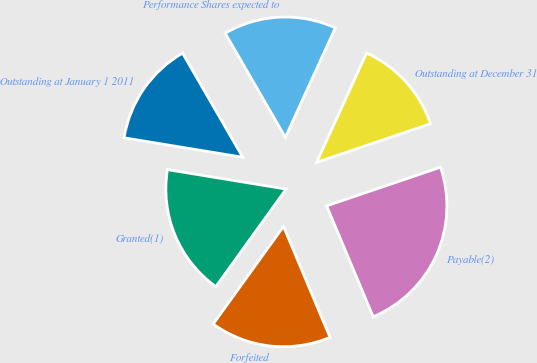<chart> <loc_0><loc_0><loc_500><loc_500><pie_chart><fcel>Outstanding at January 1 2011<fcel>Granted(1)<fcel>Forfeited<fcel>Payable(2)<fcel>Outstanding at December 31<fcel>Performance Shares expected to<nl><fcel>14.07%<fcel>17.65%<fcel>16.26%<fcel>23.88%<fcel>12.98%<fcel>15.16%<nl></chart> 